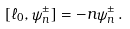<formula> <loc_0><loc_0><loc_500><loc_500>[ \ell _ { 0 } , \psi ^ { \pm } _ { n } ] = - n \psi ^ { \pm } _ { n } \, .</formula> 